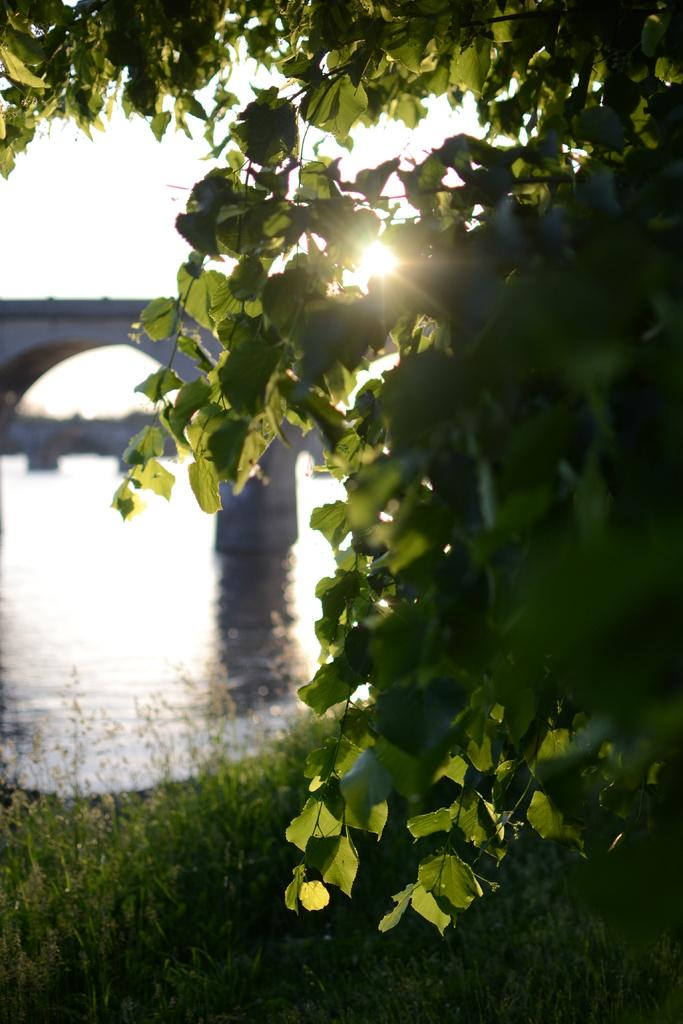What type of vegetation is present in the image? There is grass in the image. Where are the leaves located in the image? The leaves are on the right side of the image. What can be seen in the background of the image? There is water and a bridge visible in the background of the image. What type of sand can be seen in the jar in the image? There is no jar or sand present in the image. 